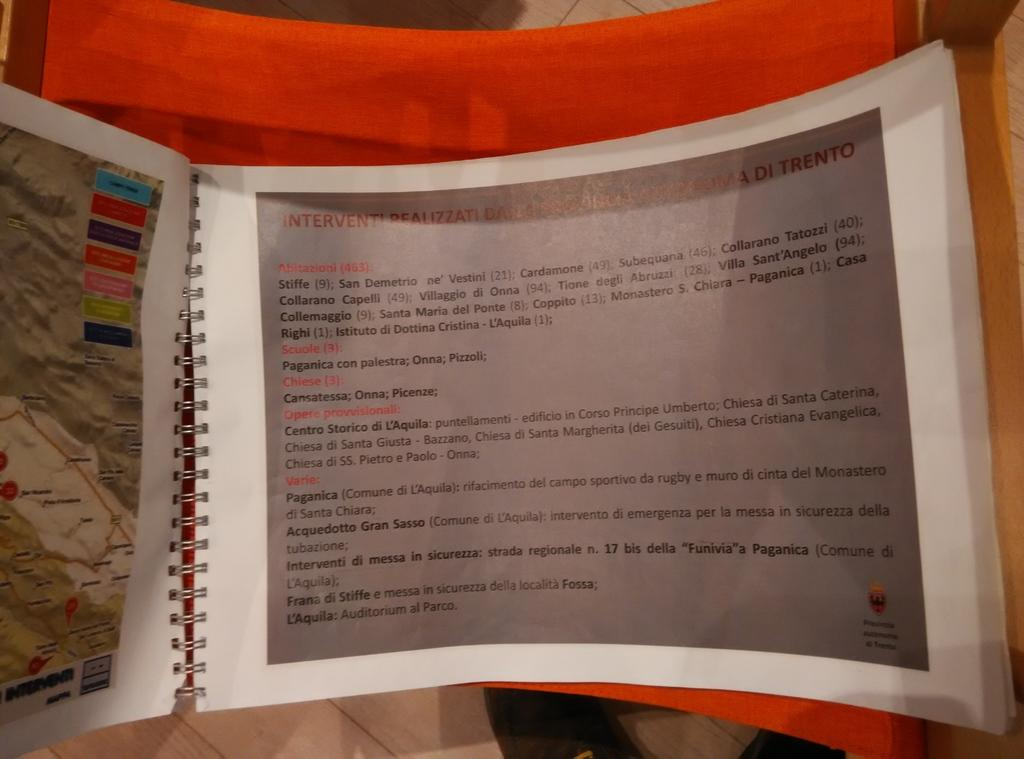<image>
Give a short and clear explanation of the subsequent image. A book is open to a page separated into sections including Varie and Chiese. 